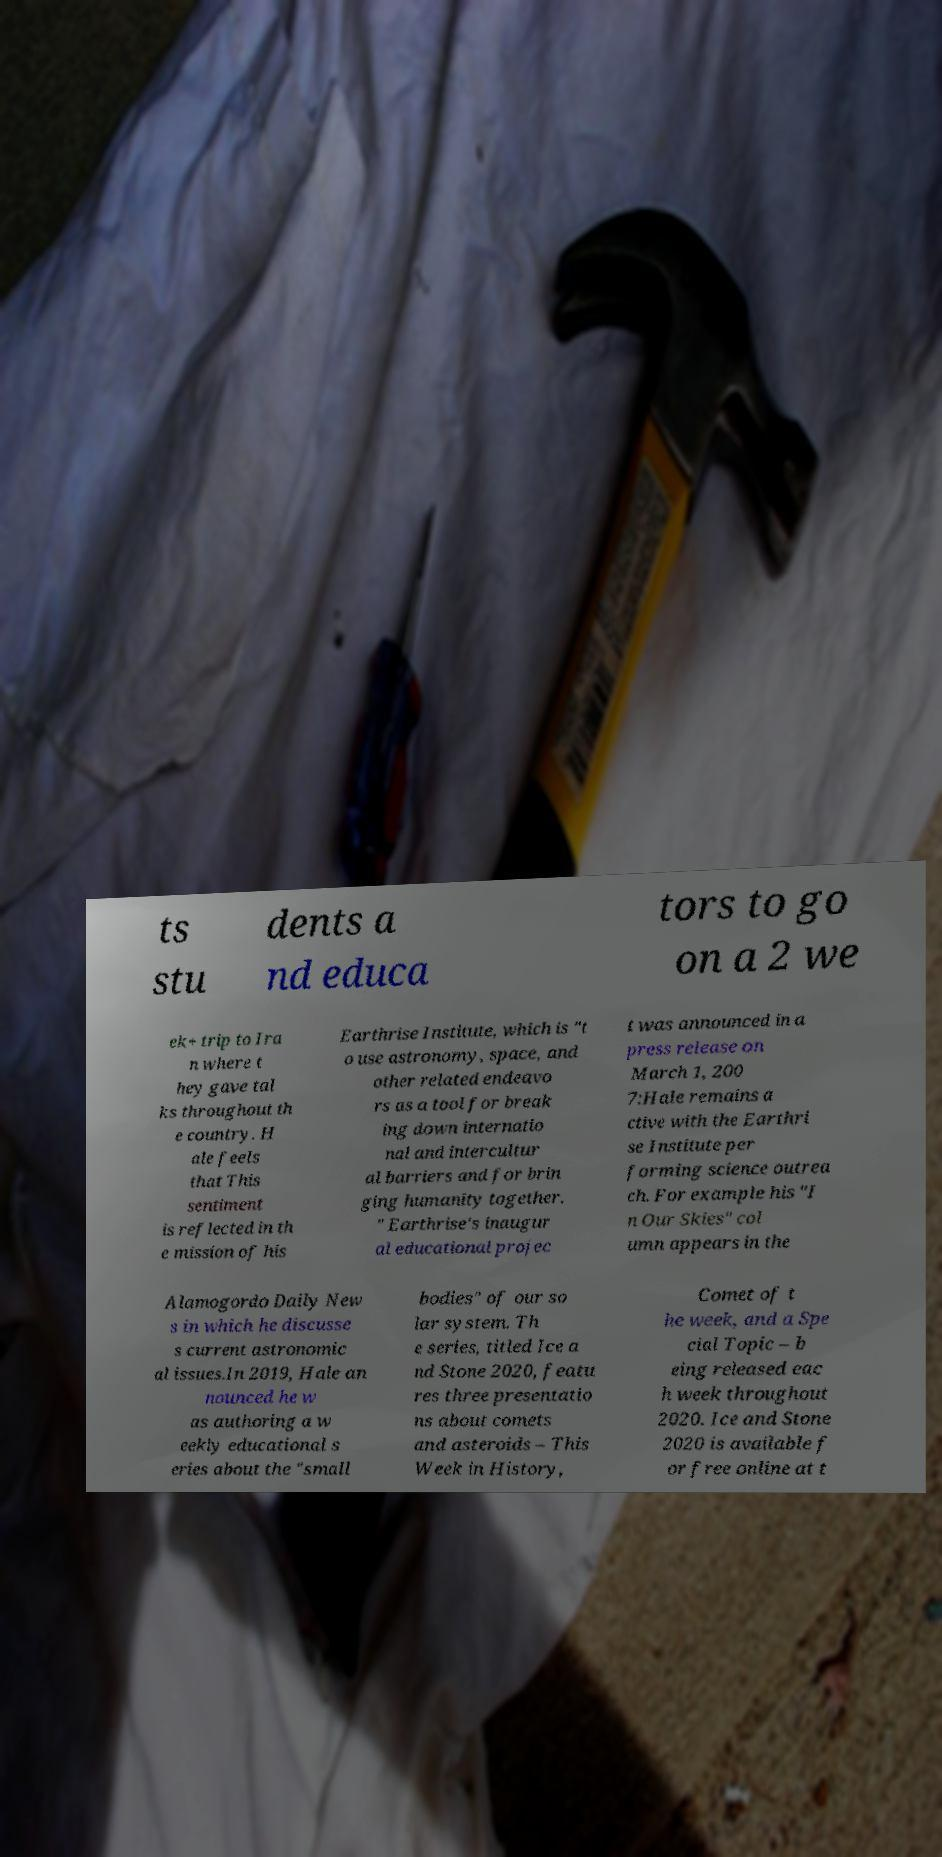There's text embedded in this image that I need extracted. Can you transcribe it verbatim? ts stu dents a nd educa tors to go on a 2 we ek+ trip to Ira n where t hey gave tal ks throughout th e country. H ale feels that This sentiment is reflected in th e mission of his Earthrise Institute, which is "t o use astronomy, space, and other related endeavo rs as a tool for break ing down internatio nal and intercultur al barriers and for brin ging humanity together. " Earthrise's inaugur al educational projec t was announced in a press release on March 1, 200 7:Hale remains a ctive with the Earthri se Institute per forming science outrea ch. For example his "I n Our Skies" col umn appears in the Alamogordo Daily New s in which he discusse s current astronomic al issues.In 2019, Hale an nounced he w as authoring a w eekly educational s eries about the "small bodies" of our so lar system. Th e series, titled Ice a nd Stone 2020, featu res three presentatio ns about comets and asteroids – This Week in History, Comet of t he week, and a Spe cial Topic – b eing released eac h week throughout 2020. Ice and Stone 2020 is available f or free online at t 